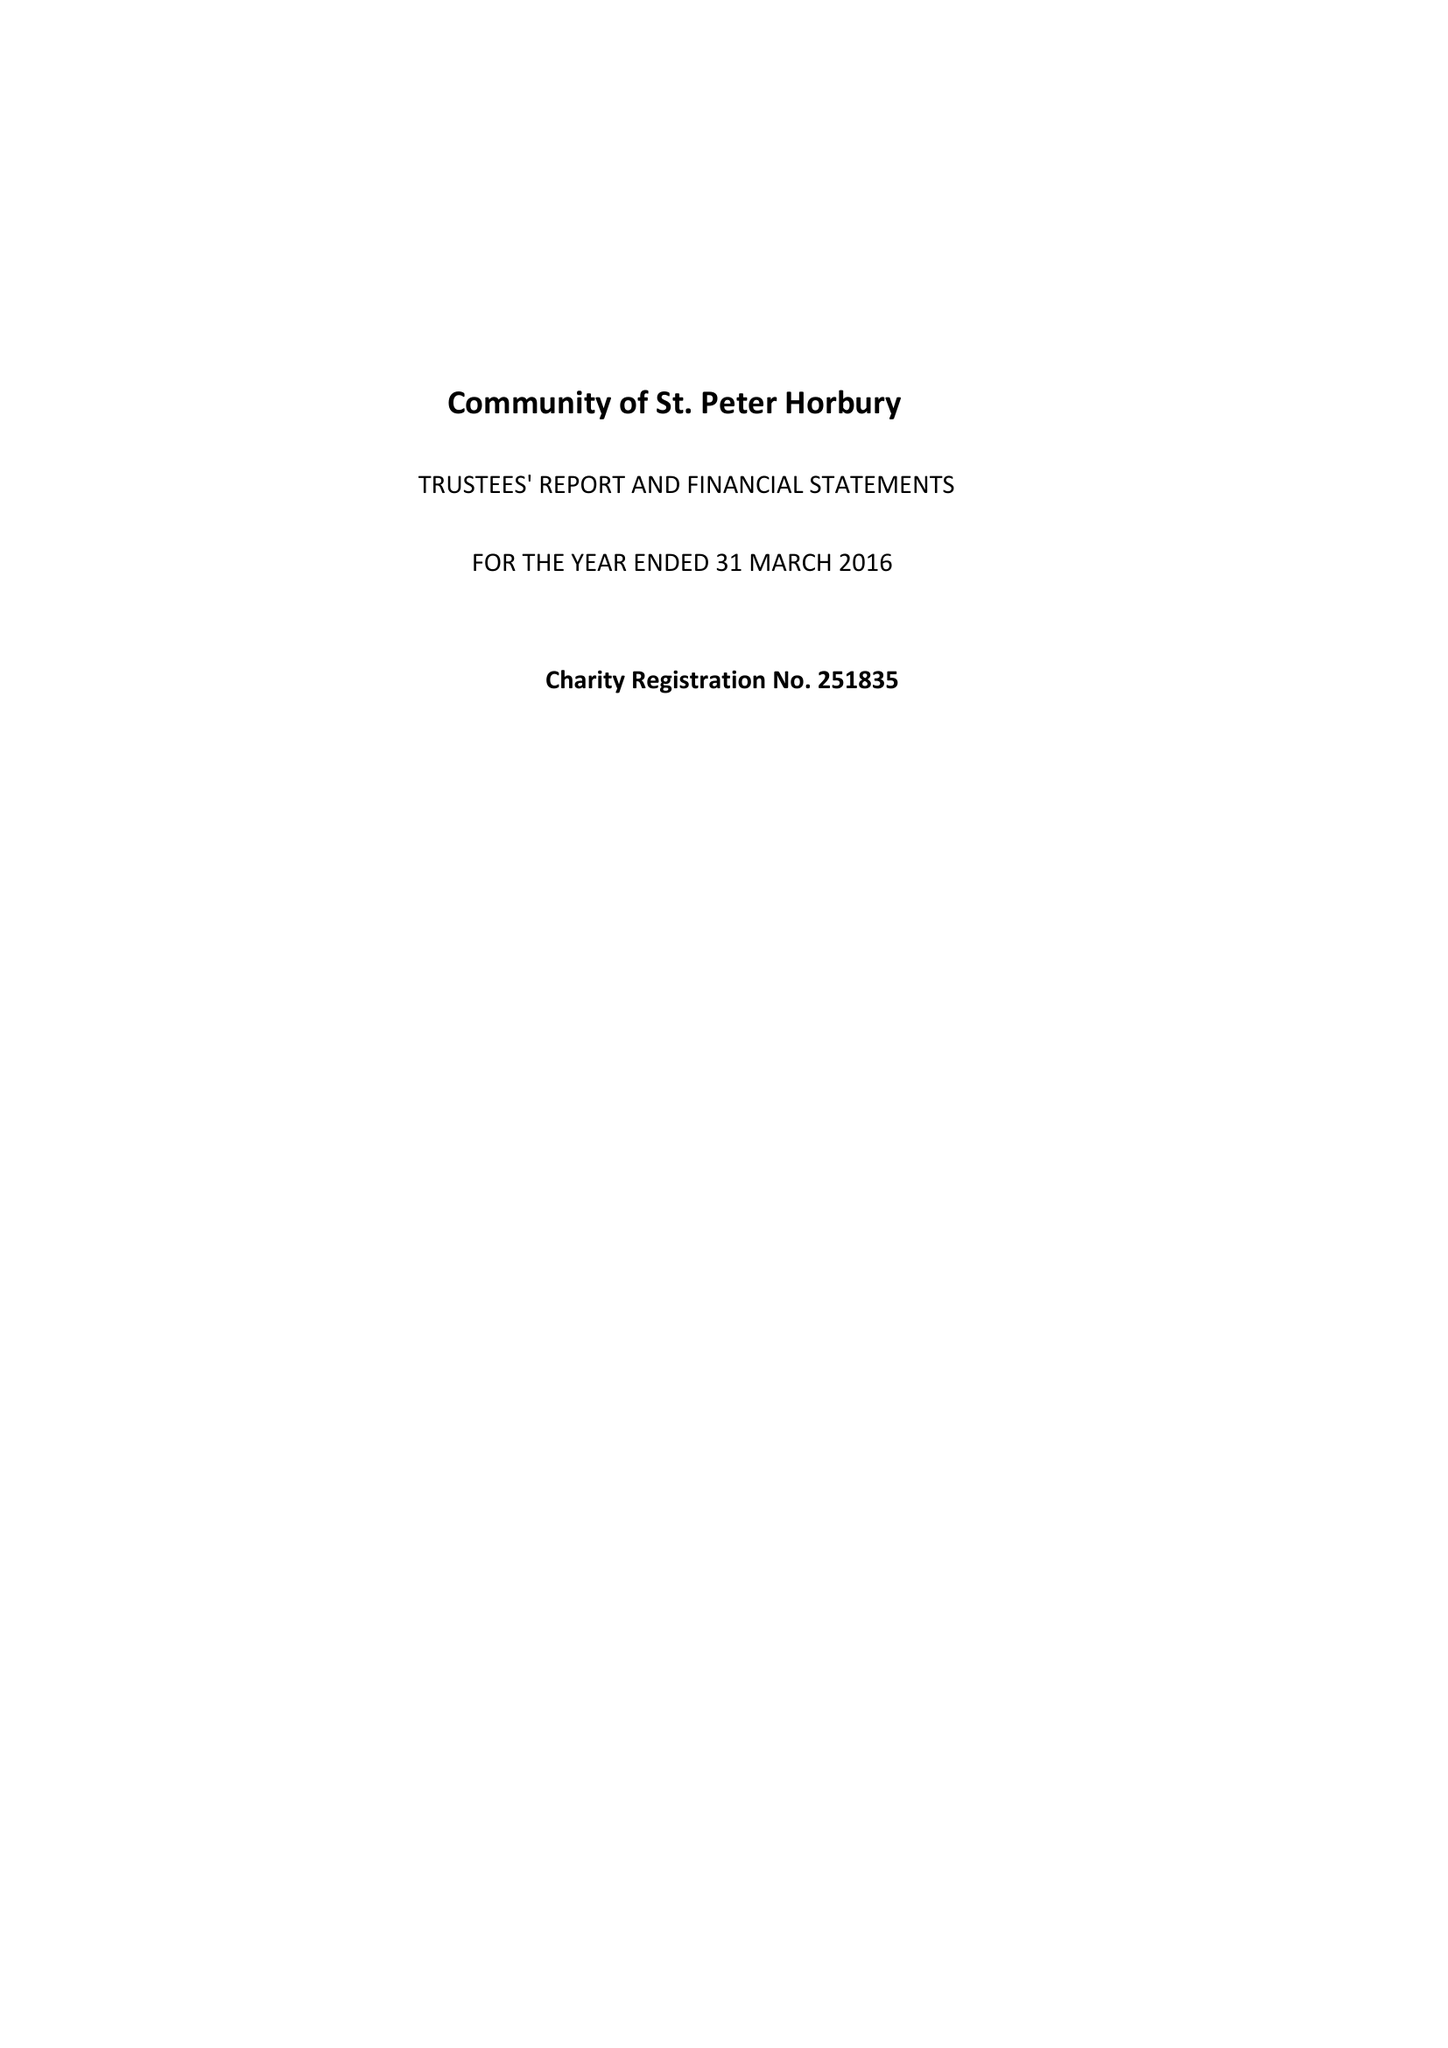What is the value for the income_annually_in_british_pounds?
Answer the question using a single word or phrase. 143756.00 